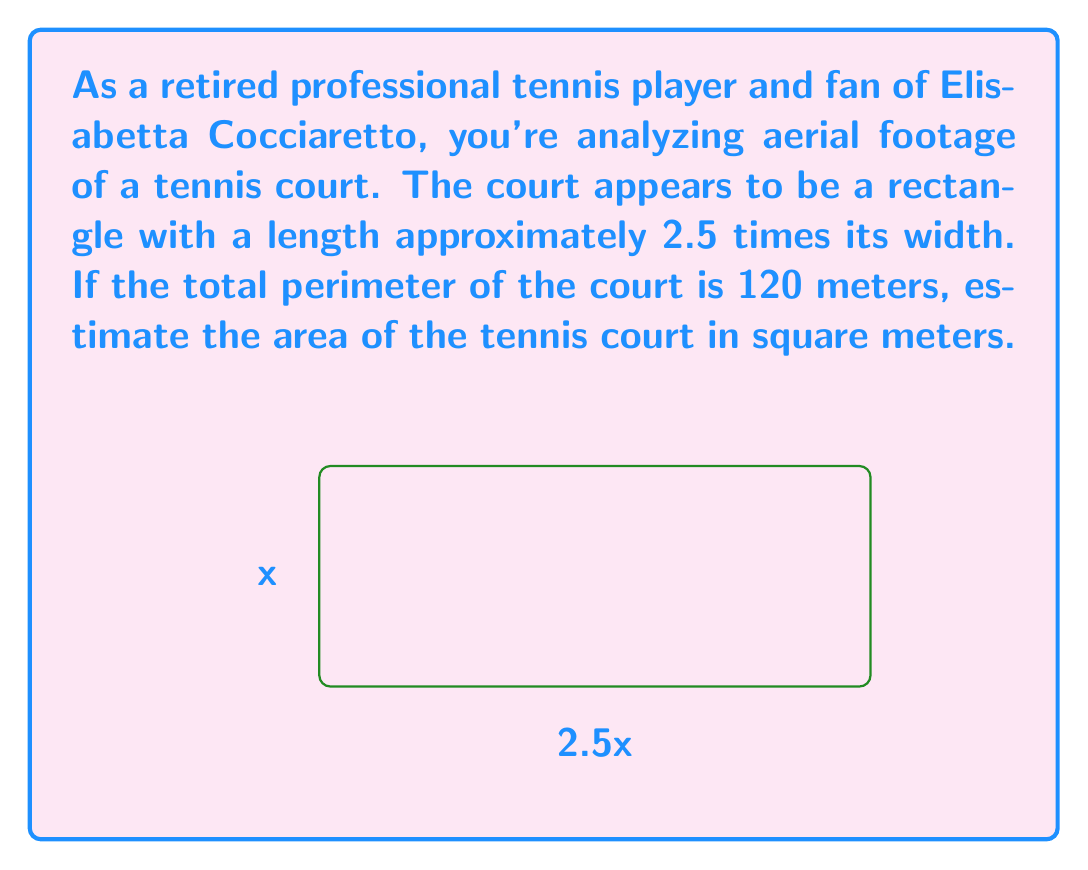Could you help me with this problem? Let's approach this step-by-step:

1) Let the width of the court be $x$ meters. Then the length is $2.5x$ meters.

2) The perimeter of a rectangle is given by the formula $P = 2l + 2w$, where $P$ is the perimeter, $l$ is the length, and $w$ is the width.

3) Substituting our values:
   
   $120 = 2(2.5x) + 2x$

4) Simplify:
   
   $120 = 5x + 2x = 7x$

5) Solve for $x$:
   
   $x = \frac{120}{7} \approx 17.14$ meters

6) Now that we have the width, we can calculate the length:
   
   $2.5x = 2.5 * 17.14 \approx 42.86$ meters

7) The area of a rectangle is given by $A = lw$. So:
   
   $A = 42.86 * 17.14 \approx 734.62$ square meters

Therefore, the estimated area of the tennis court is approximately 734.62 square meters.
Answer: $734.62$ m² 